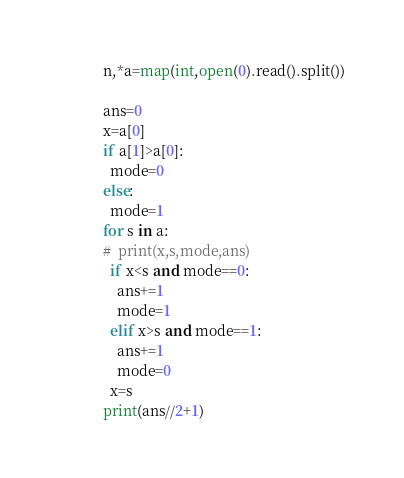<code> <loc_0><loc_0><loc_500><loc_500><_Python_>n,*a=map(int,open(0).read().split())

ans=0
x=a[0]
if a[1]>a[0]:
  mode=0
else:
  mode=1
for s in a:
#  print(x,s,mode,ans)
  if x<s and mode==0:
    ans+=1
    mode=1
  elif x>s and mode==1:
    ans+=1
    mode=0
  x=s
print(ans//2+1)</code> 